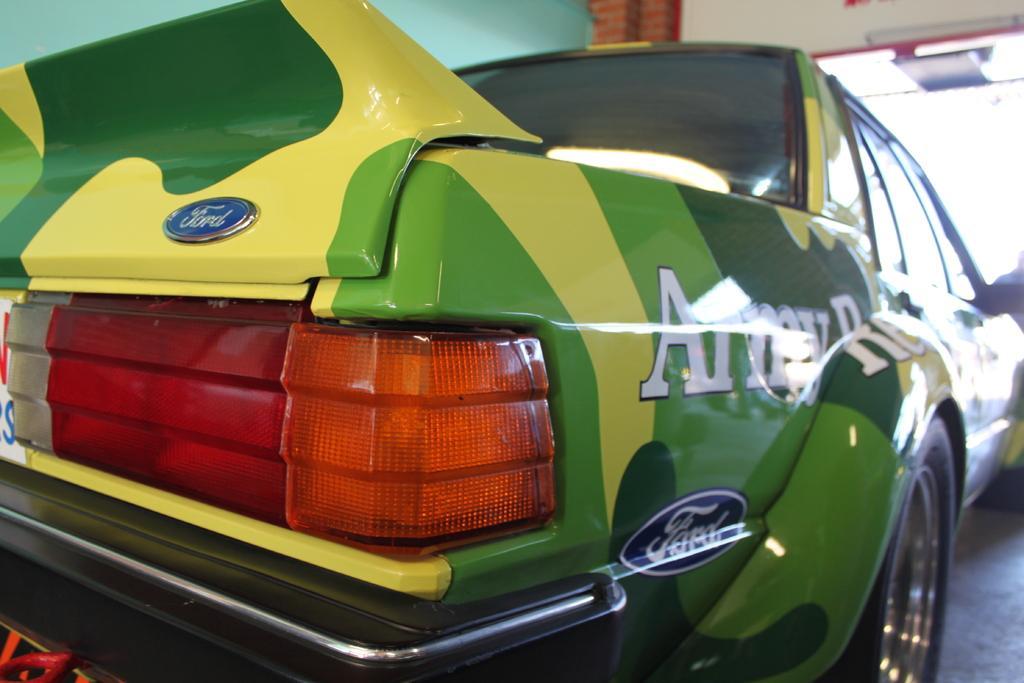In one or two sentences, can you explain what this image depicts? In this image we can see a vehicle with logo placed on the surface. In the background, we can see the wall. 